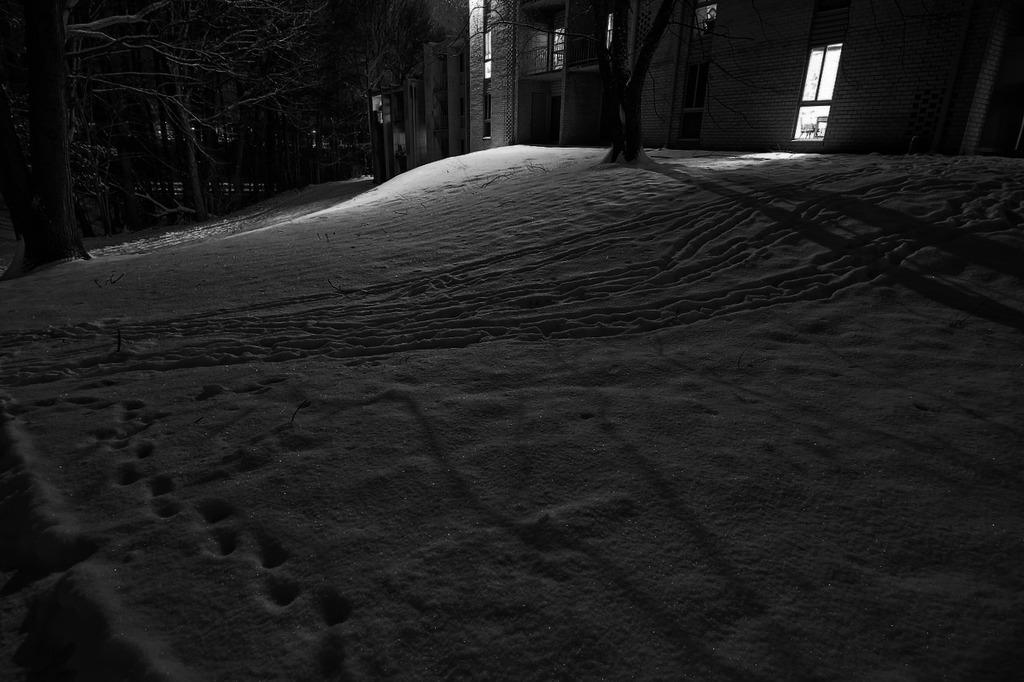What time of day is depicted in the image? The image depicts a night view. What type of terrain is visible in the image? There is a snow surface area in the image. What can be found on the snow surface area? There are trees on the snow surface area. What type of structures are present in the image? There are buildings in the image. What features do the buildings have? The buildings have windows and doors. Can you describe the woman sitting in the room with the vase in the image? There is no woman or room with a vase present in the image; it depicts a night view with a snow surface area, trees, and buildings. 